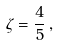Convert formula to latex. <formula><loc_0><loc_0><loc_500><loc_500>\zeta = \frac { 4 } { 5 } \, ,</formula> 